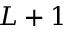<formula> <loc_0><loc_0><loc_500><loc_500>L + 1</formula> 